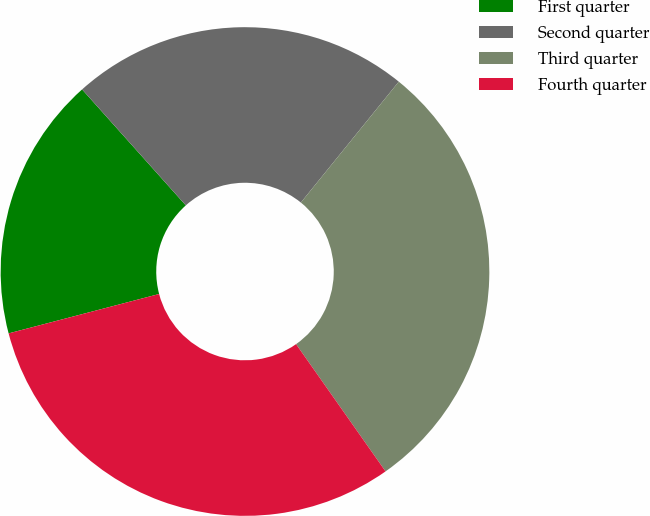Convert chart. <chart><loc_0><loc_0><loc_500><loc_500><pie_chart><fcel>First quarter<fcel>Second quarter<fcel>Third quarter<fcel>Fourth quarter<nl><fcel>17.46%<fcel>22.45%<fcel>29.41%<fcel>30.68%<nl></chart> 